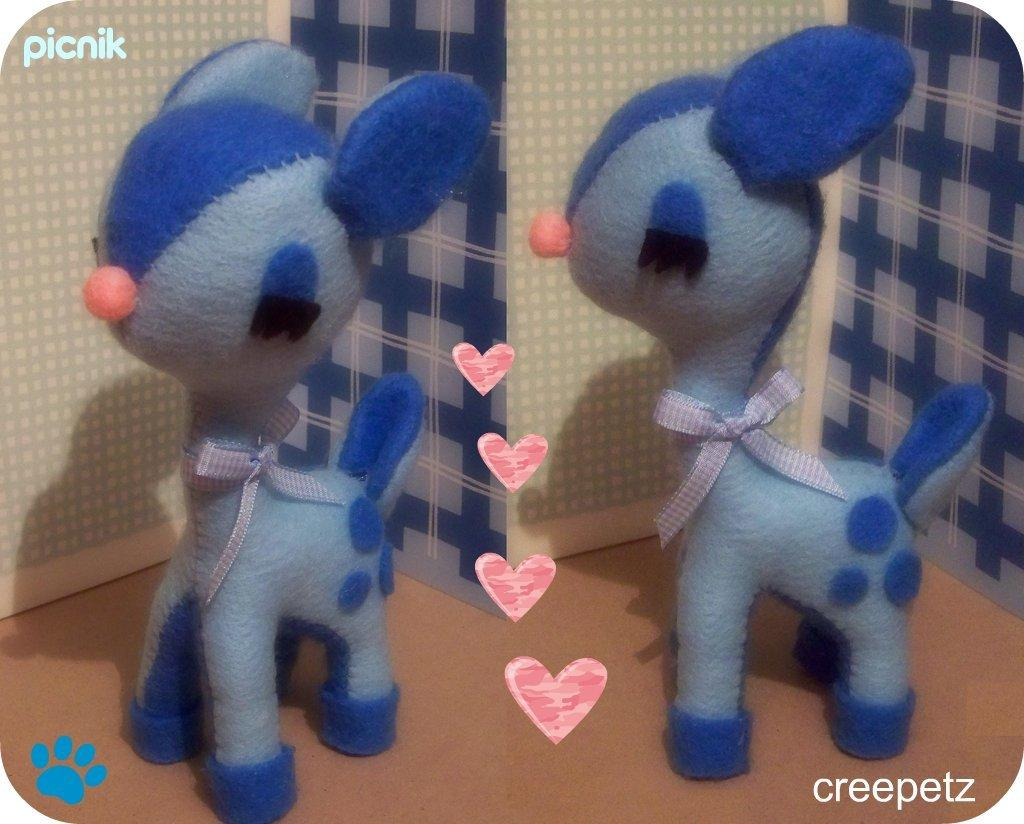What object can be seen in the image that is meant for play or amusement? There is a toy in the image. What type of visual elements are present in the image besides the toy? There are symbols and text in the image. What type of structure is visible in the image? There is a wall in the image. How many babies are present in the image? There are no babies present in the image. What idea does the actor in the image represent? There is no actor present in the image, so it is not possible to determine what idea they might represent. 